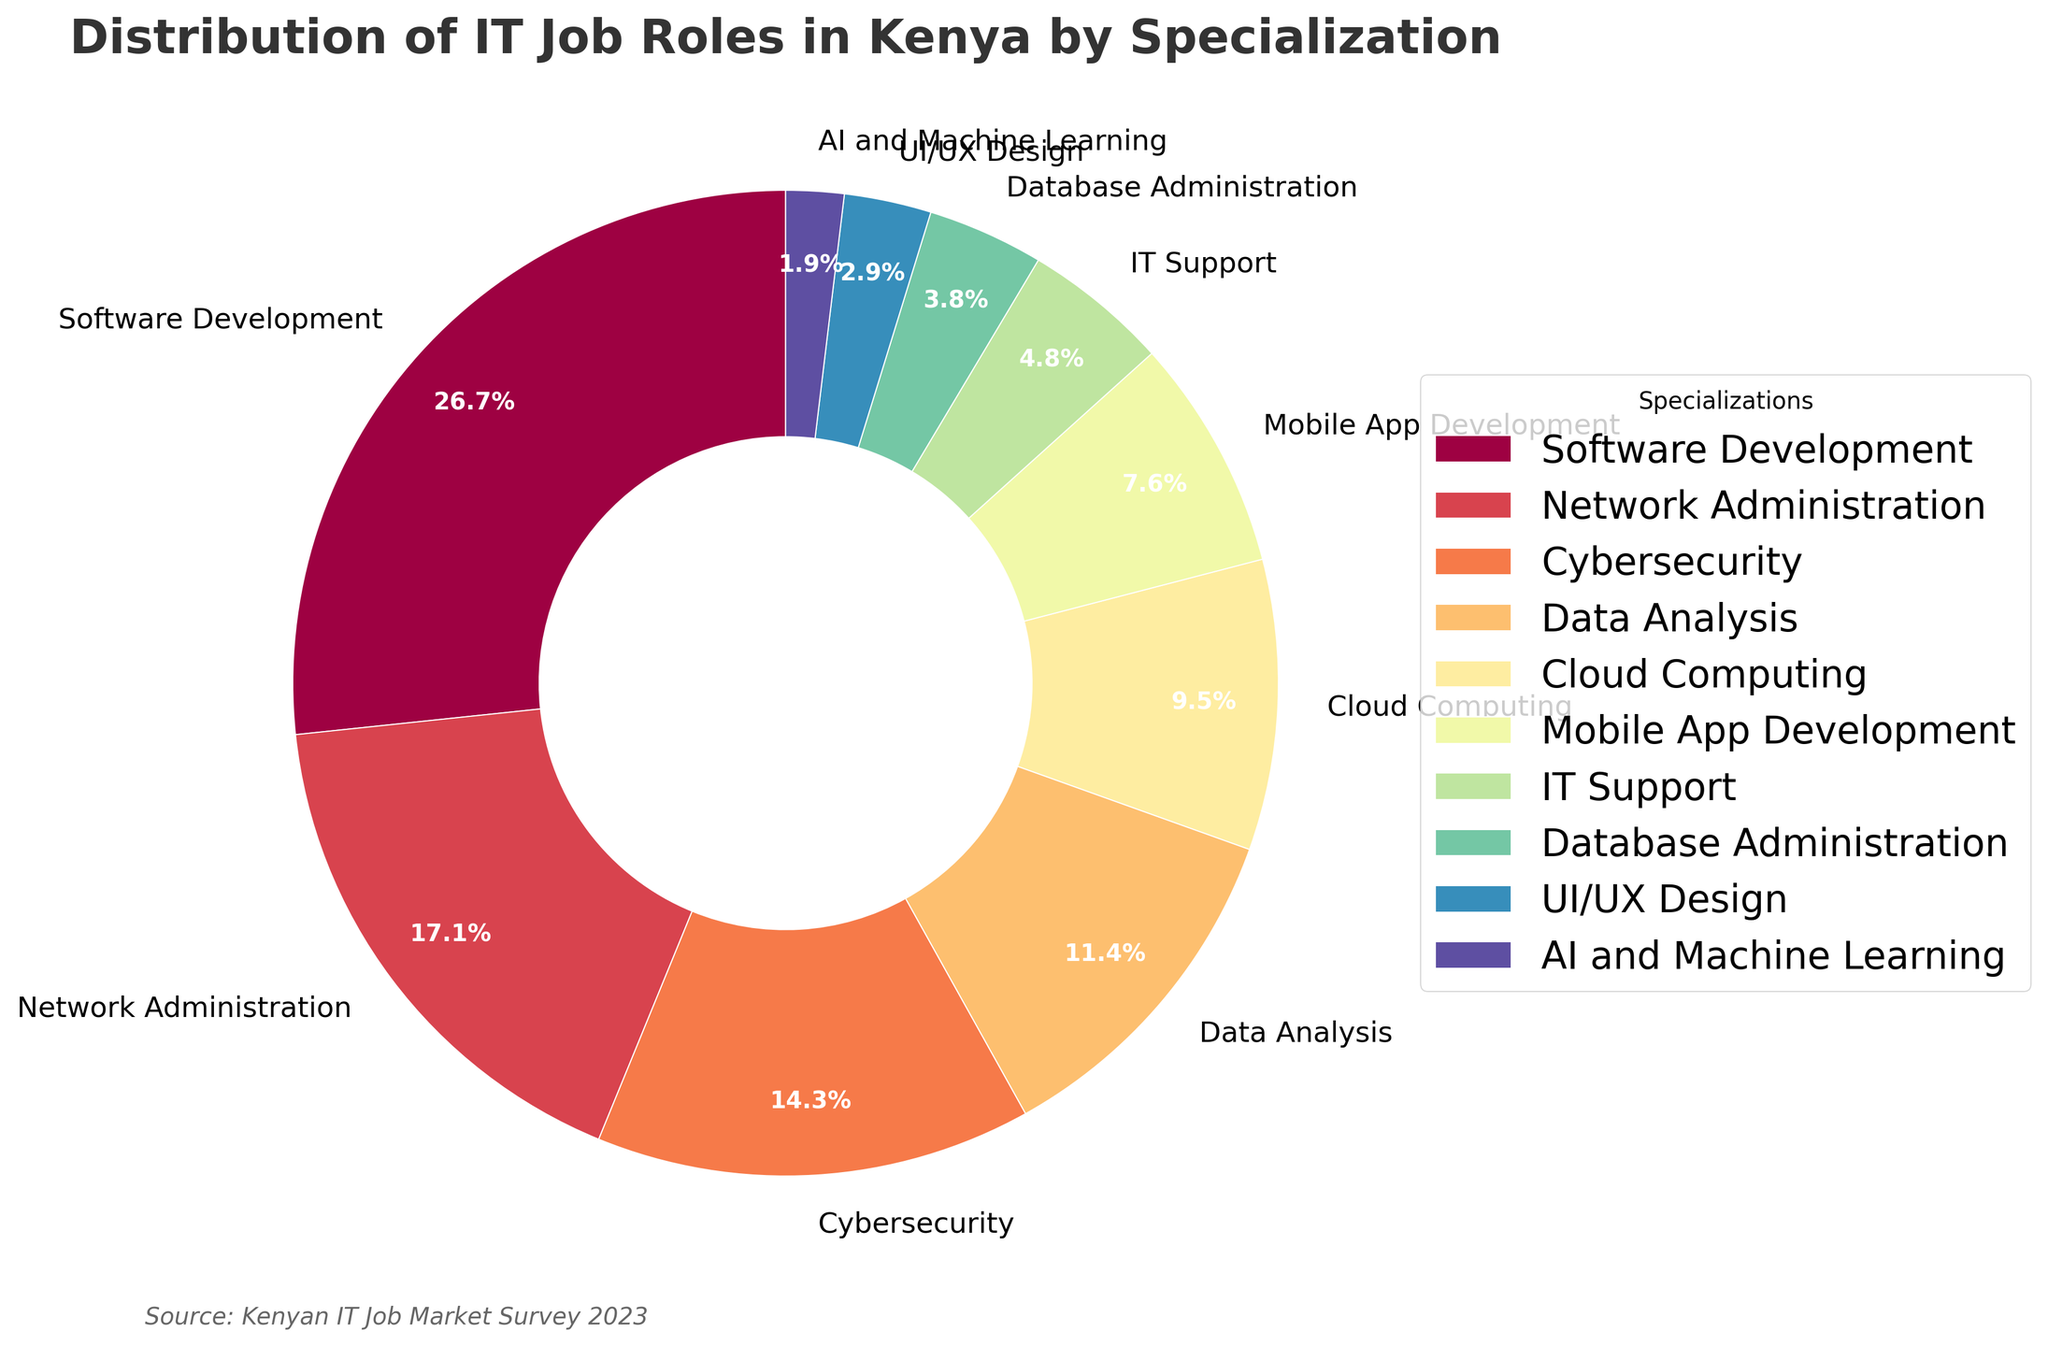What percentage of IT roles in Kenya are in Network Administration and Cybersecurity combined? To find the combined percentage, add the percentages of Network Administration and Cybersecurity. Network Administration is 18% and Cybersecurity is 15%. So, 18% + 15% = 33%.
Answer: 33% Which specialization has the smallest percentage of IT roles in Kenya? By examining the chart, the specialization with the smallest slice is AI and Machine Learning. It shows a value of 2%.
Answer: AI and Machine Learning How does the percentage of IT Support roles compare to that of Mobile App Development? IT Support roles make up 5% while Mobile App Development makes up 8%. Since 5% is less than 8%, IT Support has fewer roles than Mobile App Development.
Answer: Less What is the total percentage of IT roles in Software Development, Data Analysis, and Cloud Computing combined? Adding the percentages together: Software Development (28%) + Data Analysis (12%) + Cloud Computing (10%) gives 28% + 12% + 10% = 50%.
Answer: 50% Is the percentage of Database Administration higher or lower than UI/UX Design? Database Administration stands at 4%, whereas UI/UX Design is at 3%. Since 4% is greater than 3%, Database Administration has a higher percentage.
Answer: Higher What is the second most common IT specialization in Kenya by percentage? By identifying the largest and then the second largest portion in the pie chart, Software Development at 28% is the highest, followed by Network Administration at 18%.
Answer: Network Administration How much less is Mobile App Development's percentage compared to Software Development's percentage? Subtract the percentage of Mobile App Development (8%) from that of Software Development (28%): 28% - 8% = 20%.
Answer: 20% Which color represents the specialization with the highest percentage? By inspecting the pie chart, the specialization with the highest percentage is Software Development, associated with one of the more prominent colors, such as the one at the beginning due to the startangle=90.
Answer: [Inspect visual] 